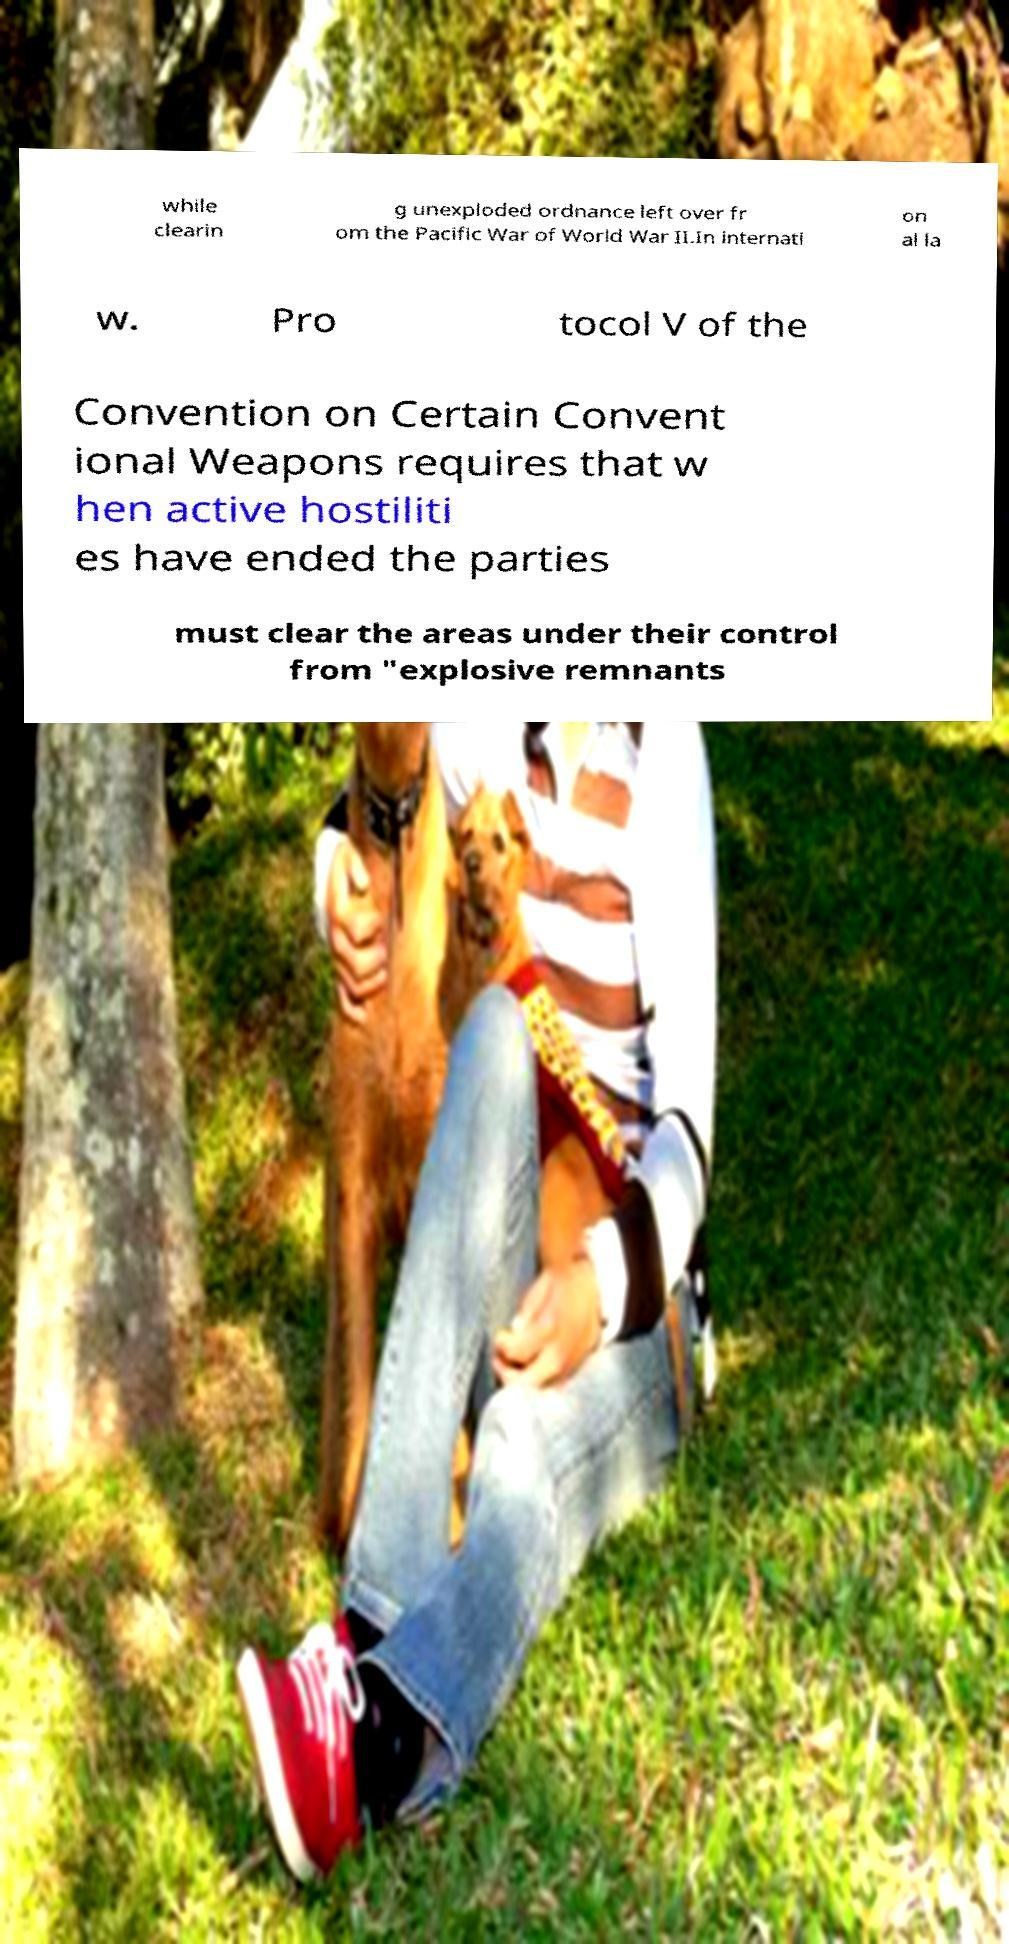Please identify and transcribe the text found in this image. while clearin g unexploded ordnance left over fr om the Pacific War of World War II.In internati on al la w. Pro tocol V of the Convention on Certain Convent ional Weapons requires that w hen active hostiliti es have ended the parties must clear the areas under their control from "explosive remnants 